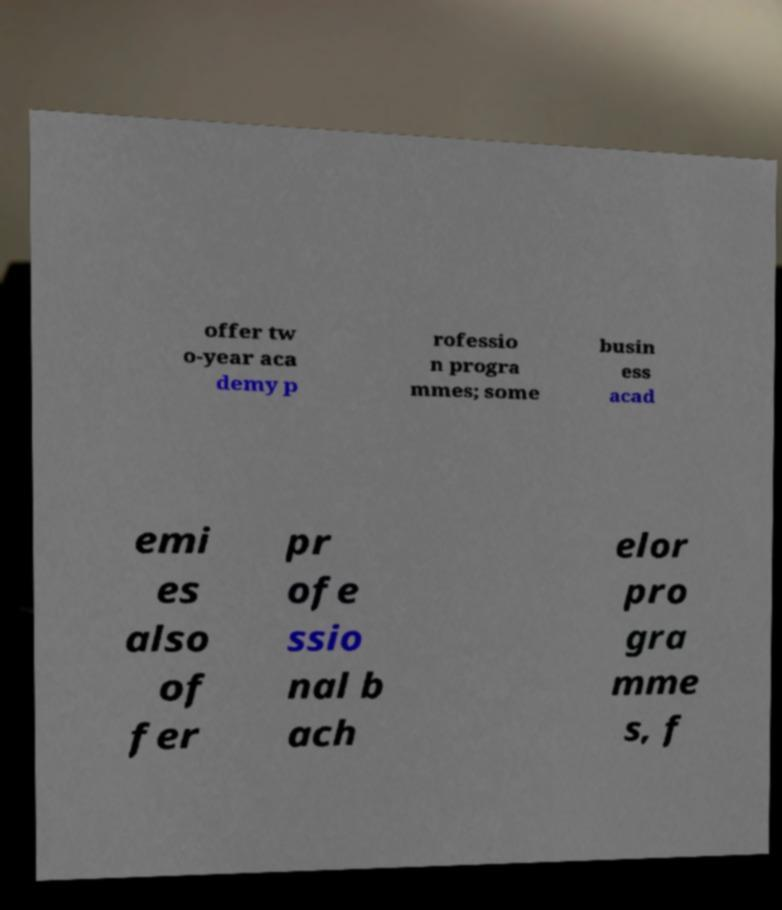Could you extract and type out the text from this image? offer tw o-year aca demy p rofessio n progra mmes; some busin ess acad emi es also of fer pr ofe ssio nal b ach elor pro gra mme s, f 